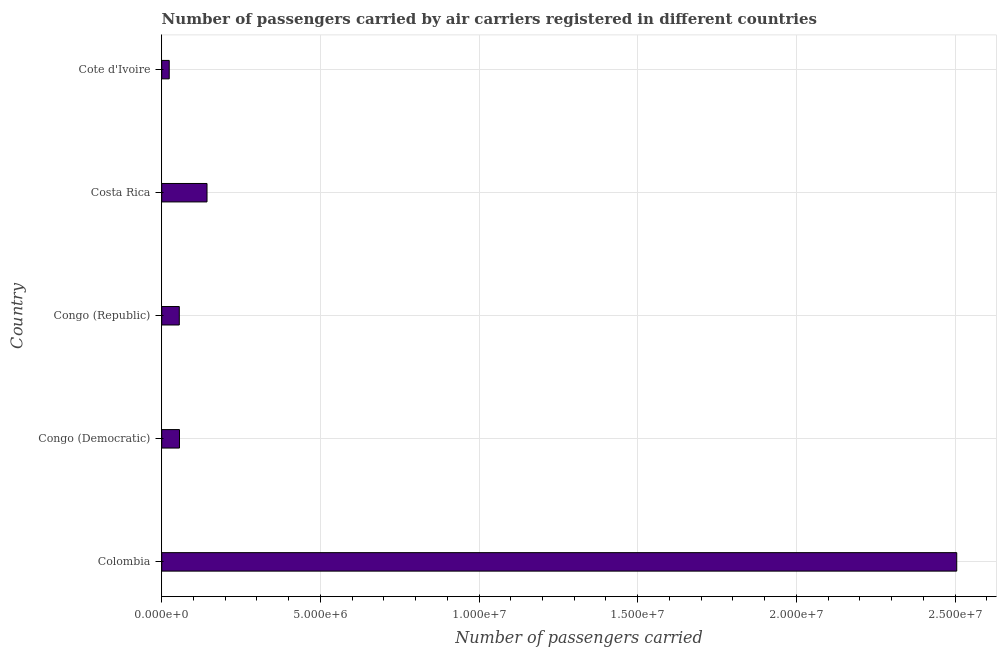What is the title of the graph?
Make the answer very short. Number of passengers carried by air carriers registered in different countries. What is the label or title of the X-axis?
Ensure brevity in your answer.  Number of passengers carried. What is the label or title of the Y-axis?
Provide a succinct answer. Country. What is the number of passengers carried in Cote d'Ivoire?
Give a very brief answer. 2.37e+05. Across all countries, what is the maximum number of passengers carried?
Offer a terse response. 2.51e+07. Across all countries, what is the minimum number of passengers carried?
Provide a succinct answer. 2.37e+05. In which country was the number of passengers carried maximum?
Ensure brevity in your answer.  Colombia. In which country was the number of passengers carried minimum?
Provide a short and direct response. Cote d'Ivoire. What is the sum of the number of passengers carried?
Make the answer very short. 2.78e+07. What is the difference between the number of passengers carried in Congo (Democratic) and Costa Rica?
Your answer should be very brief. -8.67e+05. What is the average number of passengers carried per country?
Offer a very short reply. 5.57e+06. What is the median number of passengers carried?
Provide a succinct answer. 5.60e+05. In how many countries, is the number of passengers carried greater than 7000000 ?
Offer a terse response. 1. What is the ratio of the number of passengers carried in Colombia to that in Congo (Republic)?
Provide a short and direct response. 45.23. Is the difference between the number of passengers carried in Colombia and Congo (Republic) greater than the difference between any two countries?
Keep it short and to the point. No. What is the difference between the highest and the second highest number of passengers carried?
Your response must be concise. 2.36e+07. Is the sum of the number of passengers carried in Colombia and Congo (Republic) greater than the maximum number of passengers carried across all countries?
Make the answer very short. Yes. What is the difference between the highest and the lowest number of passengers carried?
Your response must be concise. 2.48e+07. In how many countries, is the number of passengers carried greater than the average number of passengers carried taken over all countries?
Offer a terse response. 1. Are all the bars in the graph horizontal?
Your response must be concise. Yes. What is the difference between two consecutive major ticks on the X-axis?
Your answer should be compact. 5.00e+06. Are the values on the major ticks of X-axis written in scientific E-notation?
Provide a short and direct response. Yes. What is the Number of passengers carried in Colombia?
Give a very brief answer. 2.51e+07. What is the Number of passengers carried of Congo (Democratic)?
Offer a very short reply. 5.60e+05. What is the Number of passengers carried of Congo (Republic)?
Provide a short and direct response. 5.54e+05. What is the Number of passengers carried in Costa Rica?
Your answer should be compact. 1.43e+06. What is the Number of passengers carried of Cote d'Ivoire?
Keep it short and to the point. 2.37e+05. What is the difference between the Number of passengers carried in Colombia and Congo (Democratic)?
Make the answer very short. 2.45e+07. What is the difference between the Number of passengers carried in Colombia and Congo (Republic)?
Your answer should be very brief. 2.45e+07. What is the difference between the Number of passengers carried in Colombia and Costa Rica?
Your answer should be very brief. 2.36e+07. What is the difference between the Number of passengers carried in Colombia and Cote d'Ivoire?
Your response must be concise. 2.48e+07. What is the difference between the Number of passengers carried in Congo (Democratic) and Congo (Republic)?
Your answer should be very brief. 6355.09. What is the difference between the Number of passengers carried in Congo (Democratic) and Costa Rica?
Provide a succinct answer. -8.67e+05. What is the difference between the Number of passengers carried in Congo (Democratic) and Cote d'Ivoire?
Your answer should be very brief. 3.23e+05. What is the difference between the Number of passengers carried in Congo (Republic) and Costa Rica?
Keep it short and to the point. -8.73e+05. What is the difference between the Number of passengers carried in Congo (Republic) and Cote d'Ivoire?
Ensure brevity in your answer.  3.17e+05. What is the difference between the Number of passengers carried in Costa Rica and Cote d'Ivoire?
Make the answer very short. 1.19e+06. What is the ratio of the Number of passengers carried in Colombia to that in Congo (Democratic)?
Offer a terse response. 44.71. What is the ratio of the Number of passengers carried in Colombia to that in Congo (Republic)?
Ensure brevity in your answer.  45.23. What is the ratio of the Number of passengers carried in Colombia to that in Costa Rica?
Your answer should be very brief. 17.55. What is the ratio of the Number of passengers carried in Colombia to that in Cote d'Ivoire?
Keep it short and to the point. 105.66. What is the ratio of the Number of passengers carried in Congo (Democratic) to that in Costa Rica?
Offer a very short reply. 0.39. What is the ratio of the Number of passengers carried in Congo (Democratic) to that in Cote d'Ivoire?
Your answer should be compact. 2.36. What is the ratio of the Number of passengers carried in Congo (Republic) to that in Costa Rica?
Provide a succinct answer. 0.39. What is the ratio of the Number of passengers carried in Congo (Republic) to that in Cote d'Ivoire?
Offer a terse response. 2.34. What is the ratio of the Number of passengers carried in Costa Rica to that in Cote d'Ivoire?
Provide a short and direct response. 6.02. 